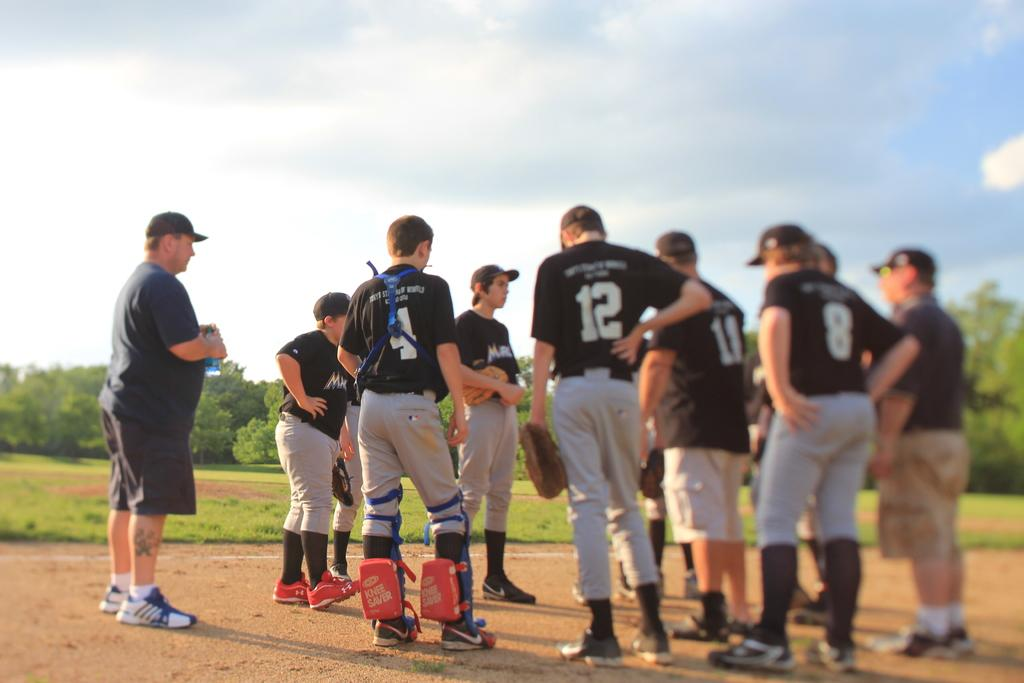<image>
Share a concise interpretation of the image provided. The baseball teams catcher is wearing number 4 